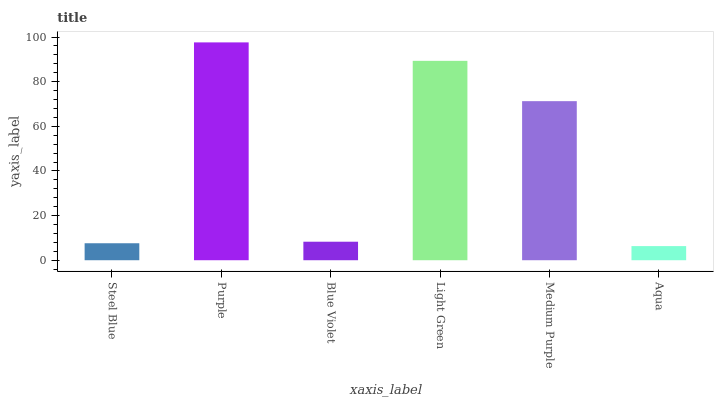Is Aqua the minimum?
Answer yes or no. Yes. Is Purple the maximum?
Answer yes or no. Yes. Is Blue Violet the minimum?
Answer yes or no. No. Is Blue Violet the maximum?
Answer yes or no. No. Is Purple greater than Blue Violet?
Answer yes or no. Yes. Is Blue Violet less than Purple?
Answer yes or no. Yes. Is Blue Violet greater than Purple?
Answer yes or no. No. Is Purple less than Blue Violet?
Answer yes or no. No. Is Medium Purple the high median?
Answer yes or no. Yes. Is Blue Violet the low median?
Answer yes or no. Yes. Is Purple the high median?
Answer yes or no. No. Is Purple the low median?
Answer yes or no. No. 